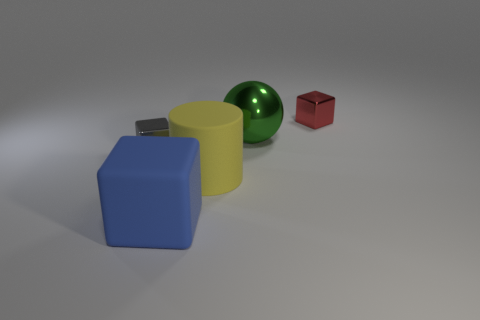Add 1 small red spheres. How many objects exist? 6 Subtract all brown cylinders. Subtract all cyan cubes. How many cylinders are left? 1 Subtract all cylinders. How many objects are left? 4 Subtract 0 cyan cylinders. How many objects are left? 5 Subtract all gray metal objects. Subtract all small blue metallic objects. How many objects are left? 4 Add 2 blue matte things. How many blue matte things are left? 3 Add 3 green metal things. How many green metal things exist? 4 